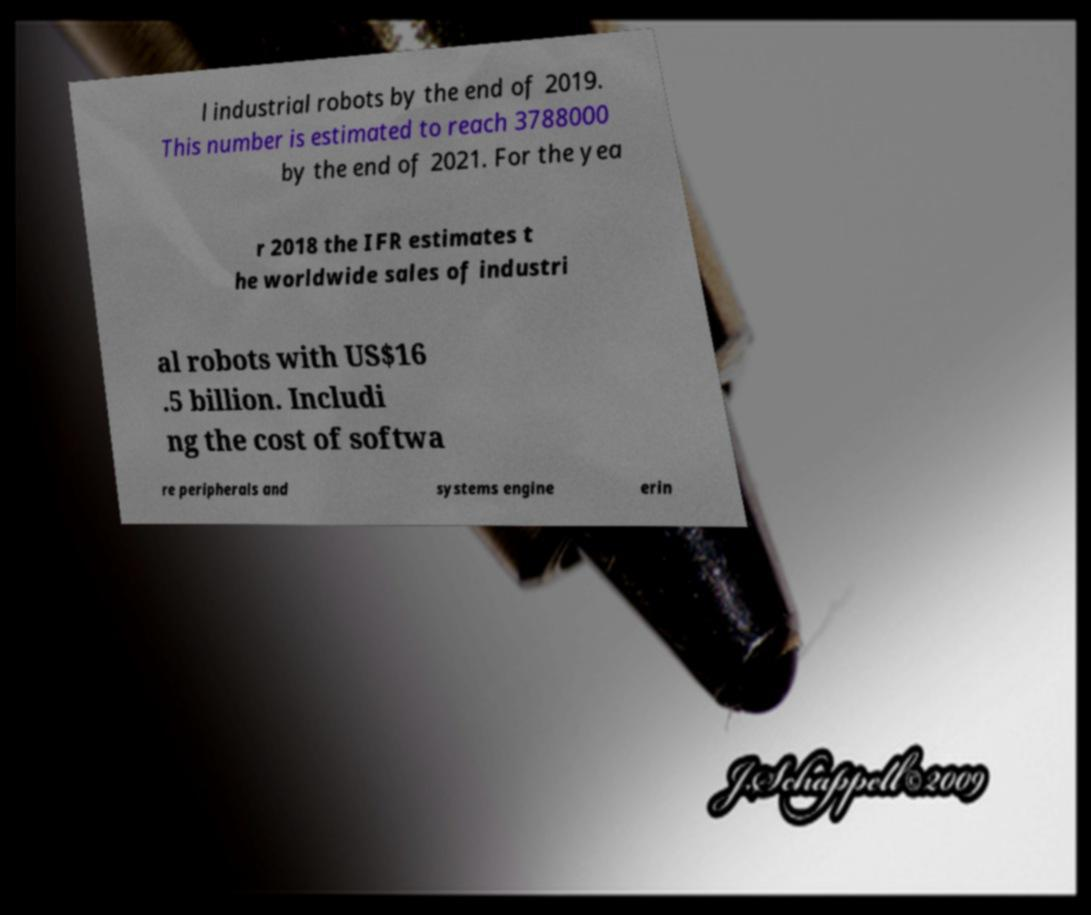Could you extract and type out the text from this image? l industrial robots by the end of 2019. This number is estimated to reach 3788000 by the end of 2021. For the yea r 2018 the IFR estimates t he worldwide sales of industri al robots with US$16 .5 billion. Includi ng the cost of softwa re peripherals and systems engine erin 